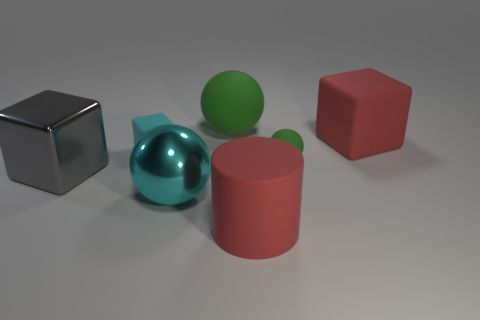Add 1 large cylinders. How many objects exist? 8 Subtract all cylinders. How many objects are left? 6 Add 5 gray metal cubes. How many gray metal cubes are left? 6 Add 6 tiny green matte cubes. How many tiny green matte cubes exist? 6 Subtract 1 cyan spheres. How many objects are left? 6 Subtract all gray things. Subtract all green matte objects. How many objects are left? 4 